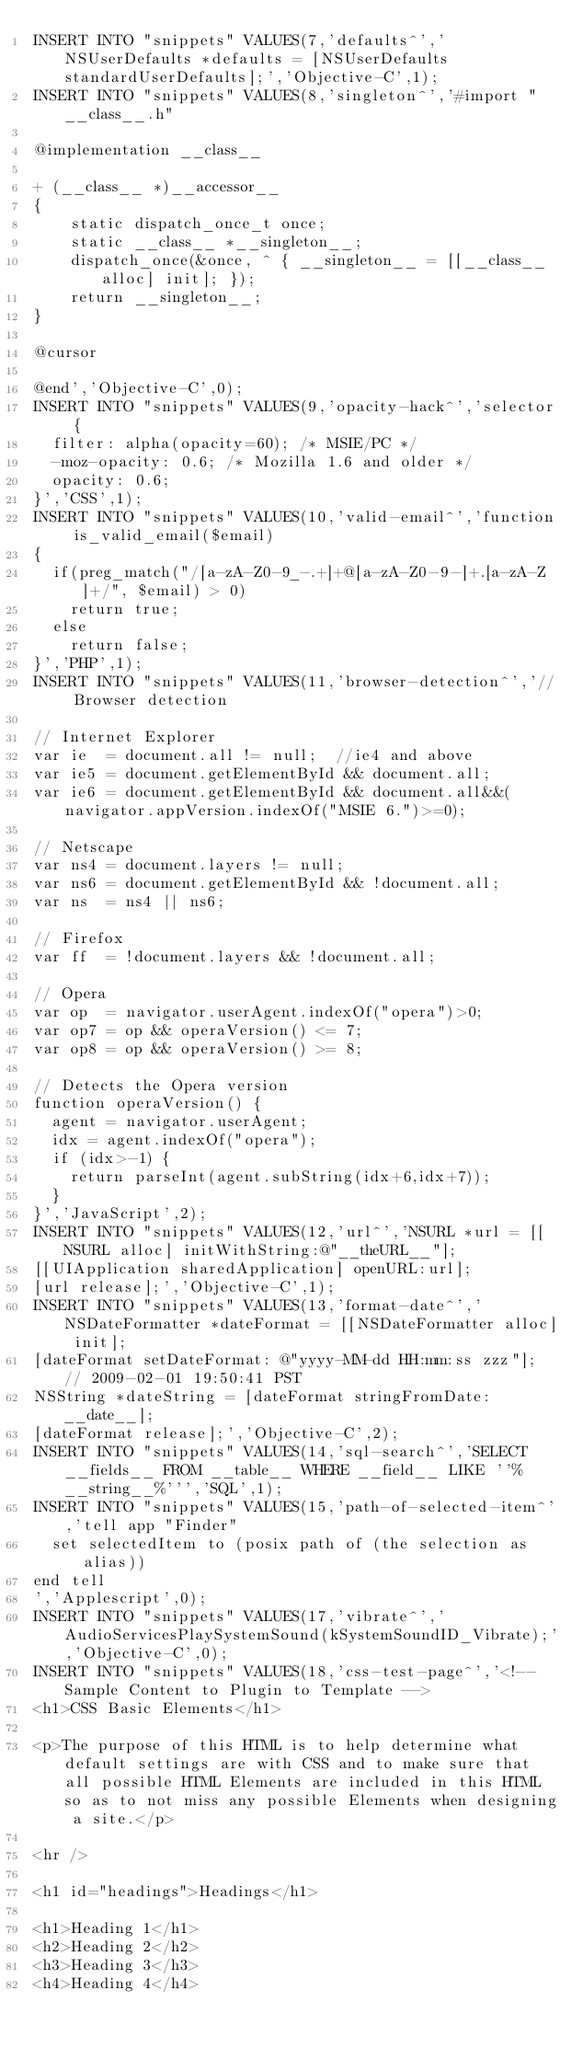Convert code to text. <code><loc_0><loc_0><loc_500><loc_500><_SQL_>INSERT INTO "snippets" VALUES(7,'defaults^','NSUserDefaults *defaults = [NSUserDefaults standardUserDefaults];','Objective-C',1);
INSERT INTO "snippets" VALUES(8,'singleton^','#import "__class__.h"

@implementation __class__

+ (__class__ *)__accessor__
{
    static dispatch_once_t once;
    static __class__ *__singleton__;
    dispatch_once(&once, ^ { __singleton__ = [[__class__ alloc] init]; });
    return __singleton__;
}

@cursor

@end','Objective-C',0);
INSERT INTO "snippets" VALUES(9,'opacity-hack^','selector {
  filter: alpha(opacity=60); /* MSIE/PC */
  -moz-opacity: 0.6; /* Mozilla 1.6 and older */
  opacity: 0.6;
}','CSS',1);
INSERT INTO "snippets" VALUES(10,'valid-email^','function is_valid_email($email)
{
	if(preg_match("/[a-zA-Z0-9_-.+]+@[a-zA-Z0-9-]+.[a-zA-Z]+/", $email) > 0)
		return true;
	else
		return false;
}','PHP',1);
INSERT INTO "snippets" VALUES(11,'browser-detection^','// Browser detection

// Internet Explorer
var ie  = document.all != null;  //ie4 and above
var ie5 = document.getElementById && document.all;
var ie6 = document.getElementById && document.all&&(navigator.appVersion.indexOf("MSIE 6.")>=0);

// Netscape
var ns4 = document.layers != null;
var ns6 = document.getElementById && !document.all;
var ns  = ns4 || ns6;

// Firefox
var ff  = !document.layers && !document.all;

// Opera
var op  = navigator.userAgent.indexOf("opera")>0;
var op7 = op && operaVersion() <= 7;
var op8 = op && operaVersion() >= 8;

// Detects the Opera version
function operaVersion() {
	agent = navigator.userAgent;
	idx = agent.indexOf("opera");	
	if (idx>-1) {
		return parseInt(agent.subString(idx+6,idx+7));
	}
}','JavaScript',2);
INSERT INTO "snippets" VALUES(12,'url^','NSURL *url = [[NSURL alloc] initWithString:@"__theURL__"];
[[UIApplication sharedApplication] openURL:url];
[url release];','Objective-C',1);
INSERT INTO "snippets" VALUES(13,'format-date^','NSDateFormatter *dateFormat = [[NSDateFormatter alloc] init];
[dateFormat setDateFormat: @"yyyy-MM-dd HH:mm:ss zzz"]; // 2009-02-01 19:50:41 PST
NSString *dateString = [dateFormat stringFromDate:__date__];
[dateFormat release];','Objective-C',2);
INSERT INTO "snippets" VALUES(14,'sql-search^','SELECT __fields__ FROM __table__ WHERE __field__ LIKE ''%__string__%''','SQL',1);
INSERT INTO "snippets" VALUES(15,'path-of-selected-item^','tell app "Finder"
	set selectedItem to (posix path of (the selection as alias))
end tell
','Applescript',0);
INSERT INTO "snippets" VALUES(17,'vibrate^','AudioServicesPlaySystemSound(kSystemSoundID_Vibrate);','Objective-C',0);
INSERT INTO "snippets" VALUES(18,'css-test-page^','<!-- Sample Content to Plugin to Template -->
<h1>CSS Basic Elements</h1>
 
<p>The purpose of this HTML is to help determine what default settings are with CSS and to make sure that all possible HTML Elements are included in this HTML so as to not miss any possible Elements when designing a site.</p>
 
<hr />
 
<h1 id="headings">Headings</h1>
 
<h1>Heading 1</h1>
<h2>Heading 2</h2>
<h3>Heading 3</h3>
<h4>Heading 4</h4></code> 